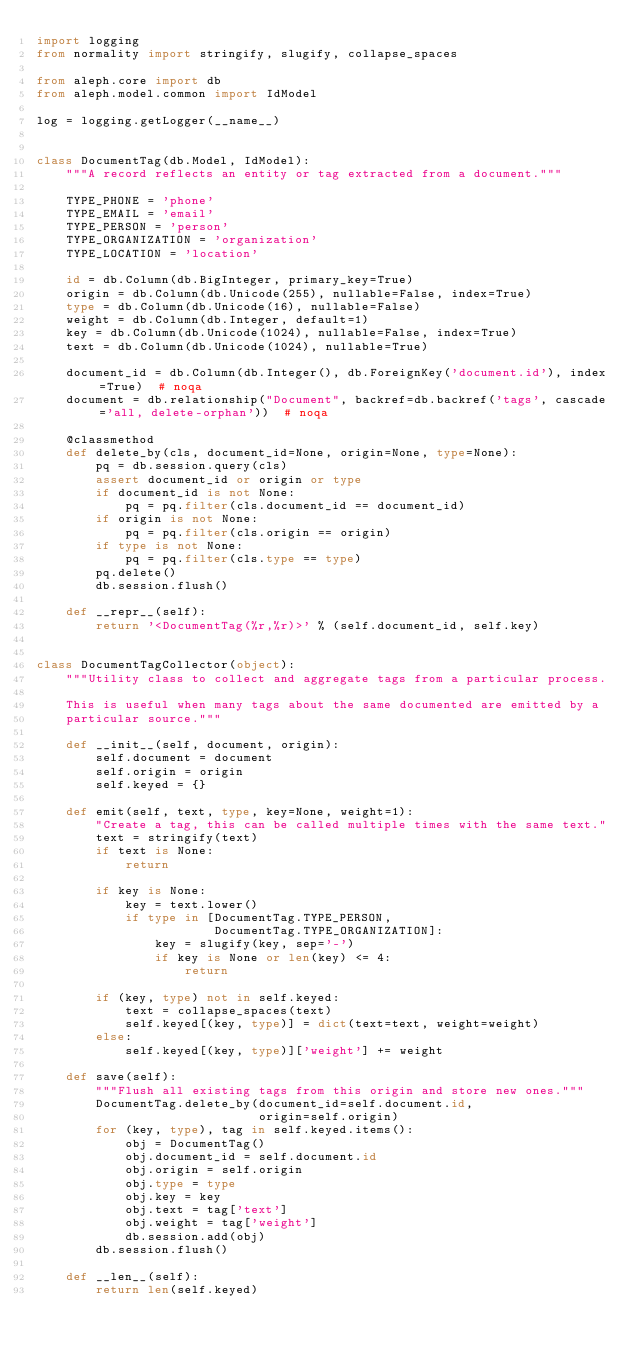Convert code to text. <code><loc_0><loc_0><loc_500><loc_500><_Python_>import logging
from normality import stringify, slugify, collapse_spaces

from aleph.core import db
from aleph.model.common import IdModel

log = logging.getLogger(__name__)


class DocumentTag(db.Model, IdModel):
    """A record reflects an entity or tag extracted from a document."""

    TYPE_PHONE = 'phone'
    TYPE_EMAIL = 'email'
    TYPE_PERSON = 'person'
    TYPE_ORGANIZATION = 'organization'
    TYPE_LOCATION = 'location'

    id = db.Column(db.BigInteger, primary_key=True)
    origin = db.Column(db.Unicode(255), nullable=False, index=True)
    type = db.Column(db.Unicode(16), nullable=False)
    weight = db.Column(db.Integer, default=1)
    key = db.Column(db.Unicode(1024), nullable=False, index=True)
    text = db.Column(db.Unicode(1024), nullable=True)

    document_id = db.Column(db.Integer(), db.ForeignKey('document.id'), index=True)  # noqa
    document = db.relationship("Document", backref=db.backref('tags', cascade='all, delete-orphan'))  # noqa

    @classmethod
    def delete_by(cls, document_id=None, origin=None, type=None):
        pq = db.session.query(cls)
        assert document_id or origin or type
        if document_id is not None:
            pq = pq.filter(cls.document_id == document_id)
        if origin is not None:
            pq = pq.filter(cls.origin == origin)
        if type is not None:
            pq = pq.filter(cls.type == type)
        pq.delete()
        db.session.flush()

    def __repr__(self):
        return '<DocumentTag(%r,%r)>' % (self.document_id, self.key)


class DocumentTagCollector(object):
    """Utility class to collect and aggregate tags from a particular process.

    This is useful when many tags about the same documented are emitted by a
    particular source."""

    def __init__(self, document, origin):
        self.document = document
        self.origin = origin
        self.keyed = {}

    def emit(self, text, type, key=None, weight=1):
        "Create a tag, this can be called multiple times with the same text."
        text = stringify(text)
        if text is None:
            return

        if key is None:
            key = text.lower()
            if type in [DocumentTag.TYPE_PERSON,
                        DocumentTag.TYPE_ORGANIZATION]:
                key = slugify(key, sep='-')
                if key is None or len(key) <= 4:
                    return

        if (key, type) not in self.keyed:
            text = collapse_spaces(text)
            self.keyed[(key, type)] = dict(text=text, weight=weight)
        else:
            self.keyed[(key, type)]['weight'] += weight

    def save(self):
        """Flush all existing tags from this origin and store new ones."""
        DocumentTag.delete_by(document_id=self.document.id,
                              origin=self.origin)
        for (key, type), tag in self.keyed.items():
            obj = DocumentTag()
            obj.document_id = self.document.id
            obj.origin = self.origin
            obj.type = type
            obj.key = key
            obj.text = tag['text']
            obj.weight = tag['weight']
            db.session.add(obj)
        db.session.flush()

    def __len__(self):
        return len(self.keyed)
</code> 